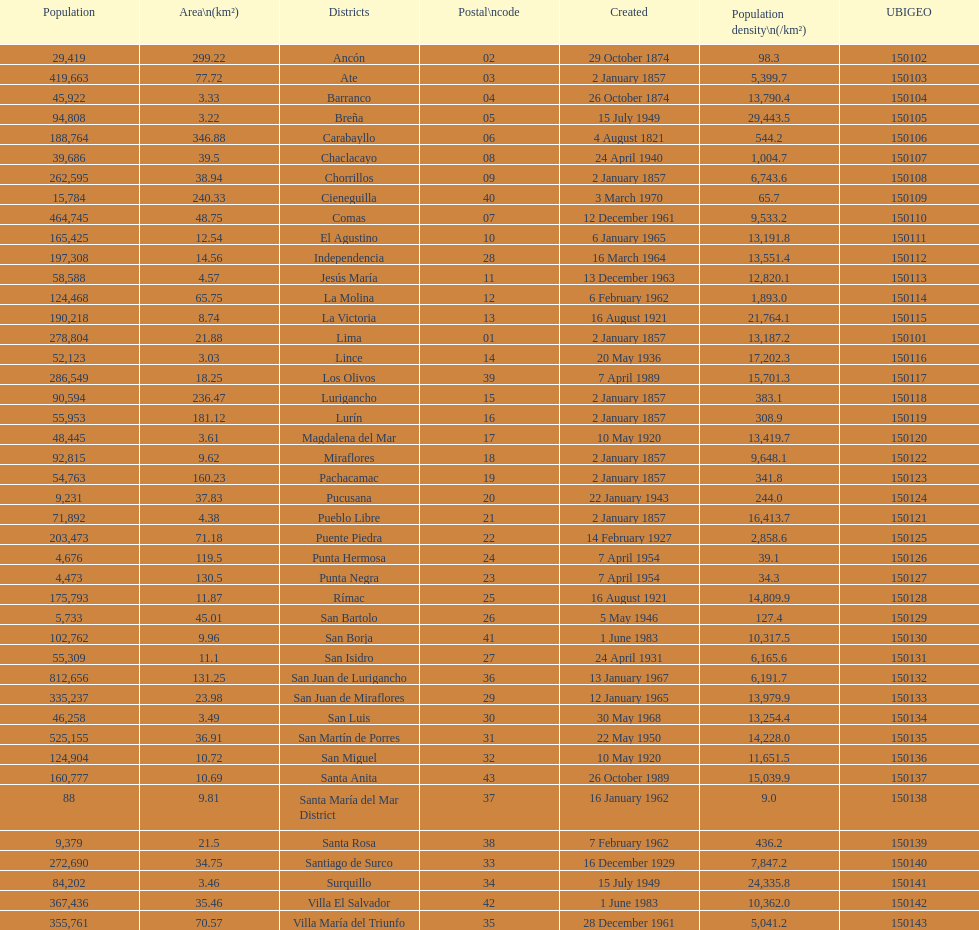What was the last district created? Santa Anita. 